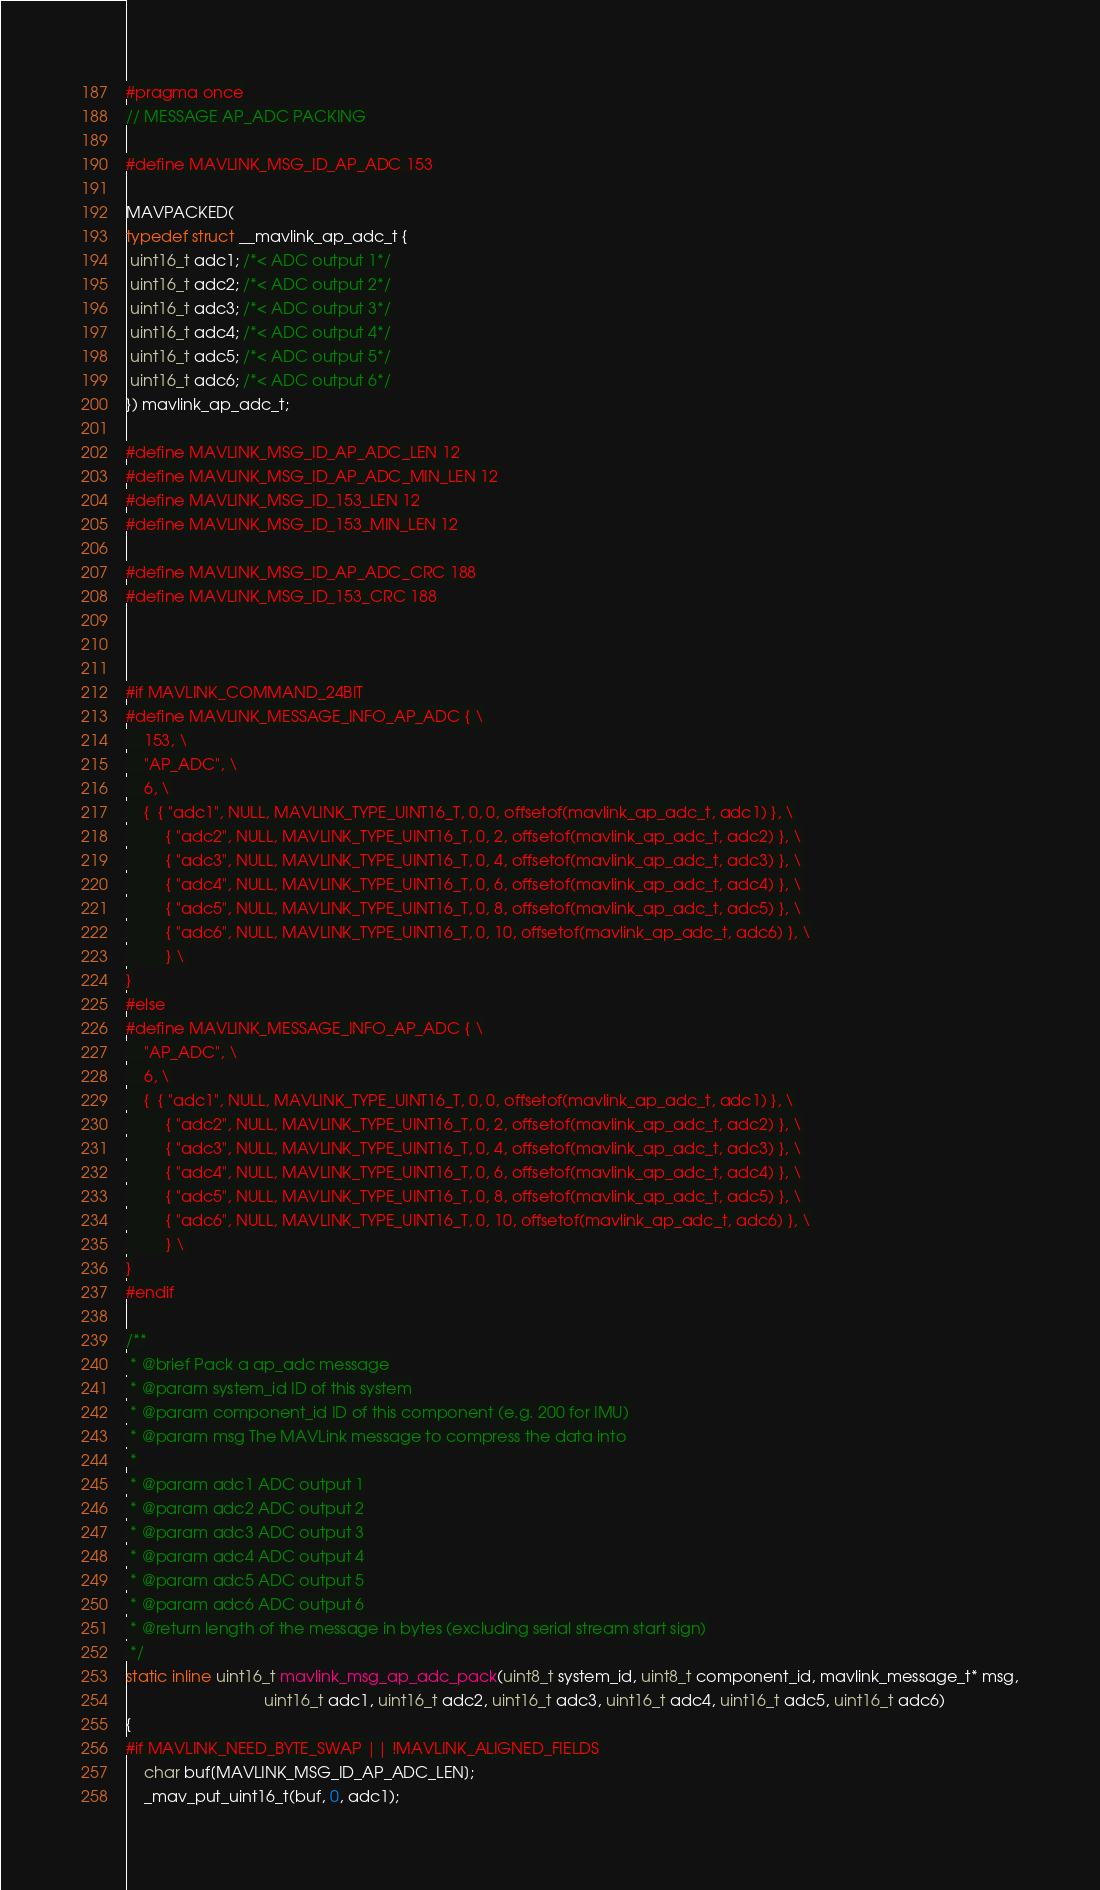Convert code to text. <code><loc_0><loc_0><loc_500><loc_500><_C_>#pragma once
// MESSAGE AP_ADC PACKING

#define MAVLINK_MSG_ID_AP_ADC 153

MAVPACKED(
typedef struct __mavlink_ap_adc_t {
 uint16_t adc1; /*< ADC output 1*/
 uint16_t adc2; /*< ADC output 2*/
 uint16_t adc3; /*< ADC output 3*/
 uint16_t adc4; /*< ADC output 4*/
 uint16_t adc5; /*< ADC output 5*/
 uint16_t adc6; /*< ADC output 6*/
}) mavlink_ap_adc_t;

#define MAVLINK_MSG_ID_AP_ADC_LEN 12
#define MAVLINK_MSG_ID_AP_ADC_MIN_LEN 12
#define MAVLINK_MSG_ID_153_LEN 12
#define MAVLINK_MSG_ID_153_MIN_LEN 12

#define MAVLINK_MSG_ID_AP_ADC_CRC 188
#define MAVLINK_MSG_ID_153_CRC 188



#if MAVLINK_COMMAND_24BIT
#define MAVLINK_MESSAGE_INFO_AP_ADC { \
    153, \
    "AP_ADC", \
    6, \
    {  { "adc1", NULL, MAVLINK_TYPE_UINT16_T, 0, 0, offsetof(mavlink_ap_adc_t, adc1) }, \
         { "adc2", NULL, MAVLINK_TYPE_UINT16_T, 0, 2, offsetof(mavlink_ap_adc_t, adc2) }, \
         { "adc3", NULL, MAVLINK_TYPE_UINT16_T, 0, 4, offsetof(mavlink_ap_adc_t, adc3) }, \
         { "adc4", NULL, MAVLINK_TYPE_UINT16_T, 0, 6, offsetof(mavlink_ap_adc_t, adc4) }, \
         { "adc5", NULL, MAVLINK_TYPE_UINT16_T, 0, 8, offsetof(mavlink_ap_adc_t, adc5) }, \
         { "adc6", NULL, MAVLINK_TYPE_UINT16_T, 0, 10, offsetof(mavlink_ap_adc_t, adc6) }, \
         } \
}
#else
#define MAVLINK_MESSAGE_INFO_AP_ADC { \
    "AP_ADC", \
    6, \
    {  { "adc1", NULL, MAVLINK_TYPE_UINT16_T, 0, 0, offsetof(mavlink_ap_adc_t, adc1) }, \
         { "adc2", NULL, MAVLINK_TYPE_UINT16_T, 0, 2, offsetof(mavlink_ap_adc_t, adc2) }, \
         { "adc3", NULL, MAVLINK_TYPE_UINT16_T, 0, 4, offsetof(mavlink_ap_adc_t, adc3) }, \
         { "adc4", NULL, MAVLINK_TYPE_UINT16_T, 0, 6, offsetof(mavlink_ap_adc_t, adc4) }, \
         { "adc5", NULL, MAVLINK_TYPE_UINT16_T, 0, 8, offsetof(mavlink_ap_adc_t, adc5) }, \
         { "adc6", NULL, MAVLINK_TYPE_UINT16_T, 0, 10, offsetof(mavlink_ap_adc_t, adc6) }, \
         } \
}
#endif

/**
 * @brief Pack a ap_adc message
 * @param system_id ID of this system
 * @param component_id ID of this component (e.g. 200 for IMU)
 * @param msg The MAVLink message to compress the data into
 *
 * @param adc1 ADC output 1
 * @param adc2 ADC output 2
 * @param adc3 ADC output 3
 * @param adc4 ADC output 4
 * @param adc5 ADC output 5
 * @param adc6 ADC output 6
 * @return length of the message in bytes (excluding serial stream start sign)
 */
static inline uint16_t mavlink_msg_ap_adc_pack(uint8_t system_id, uint8_t component_id, mavlink_message_t* msg,
                               uint16_t adc1, uint16_t adc2, uint16_t adc3, uint16_t adc4, uint16_t adc5, uint16_t adc6)
{
#if MAVLINK_NEED_BYTE_SWAP || !MAVLINK_ALIGNED_FIELDS
    char buf[MAVLINK_MSG_ID_AP_ADC_LEN];
    _mav_put_uint16_t(buf, 0, adc1);</code> 